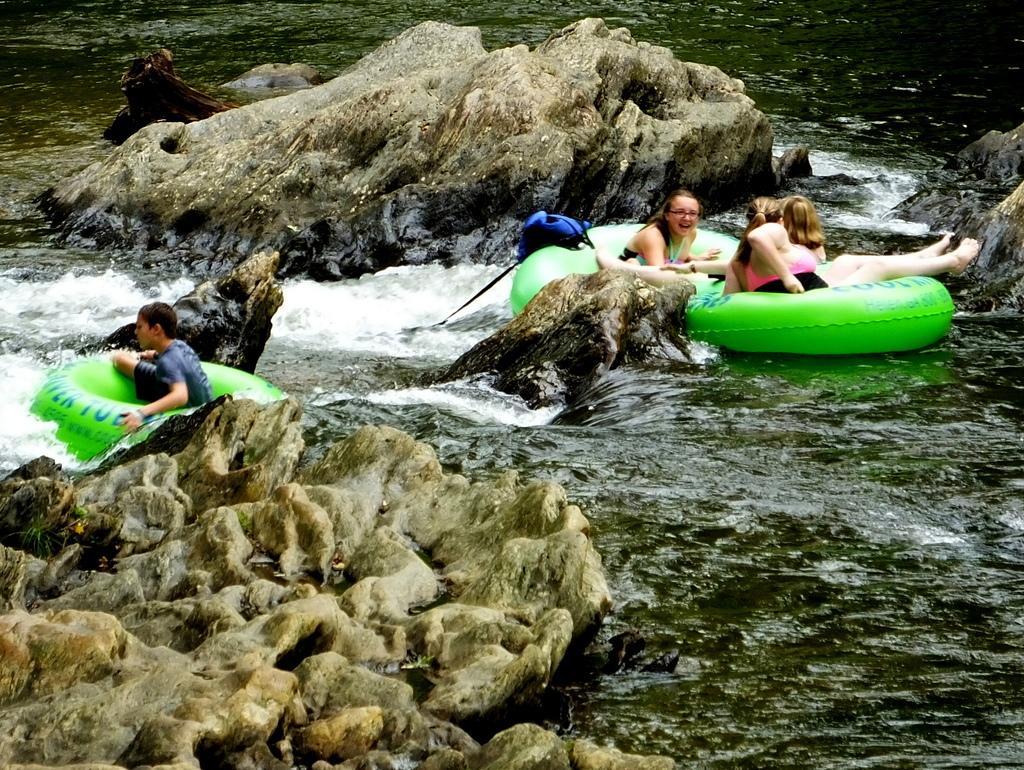Can you describe this image briefly? Here in this picture we can see rock stones present in the middle of the river over there and we can see people travelling in the water with the help of lifeboats present with them over there. 